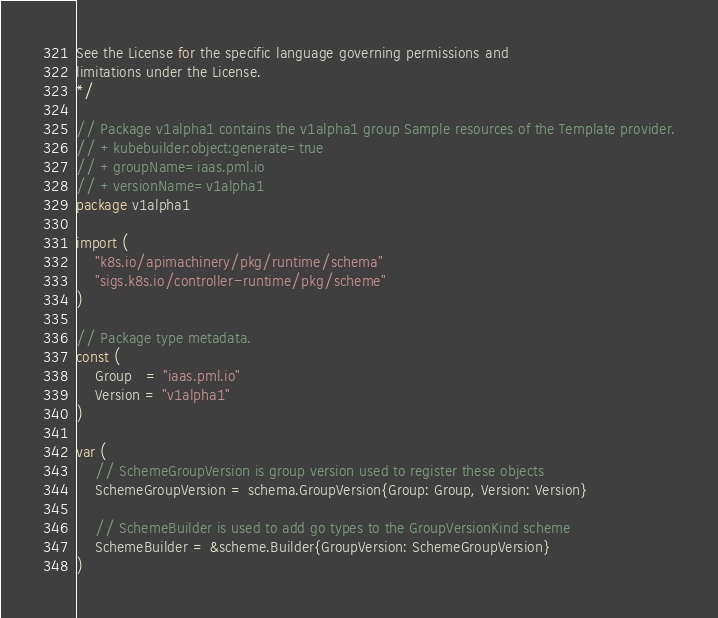Convert code to text. <code><loc_0><loc_0><loc_500><loc_500><_Go_>See the License for the specific language governing permissions and
limitations under the License.
*/

// Package v1alpha1 contains the v1alpha1 group Sample resources of the Template provider.
// +kubebuilder:object:generate=true
// +groupName=iaas.pml.io
// +versionName=v1alpha1
package v1alpha1

import (
	"k8s.io/apimachinery/pkg/runtime/schema"
	"sigs.k8s.io/controller-runtime/pkg/scheme"
)

// Package type metadata.
const (
	Group   = "iaas.pml.io"
	Version = "v1alpha1"
)

var (
	// SchemeGroupVersion is group version used to register these objects
	SchemeGroupVersion = schema.GroupVersion{Group: Group, Version: Version}

	// SchemeBuilder is used to add go types to the GroupVersionKind scheme
	SchemeBuilder = &scheme.Builder{GroupVersion: SchemeGroupVersion}
)
</code> 